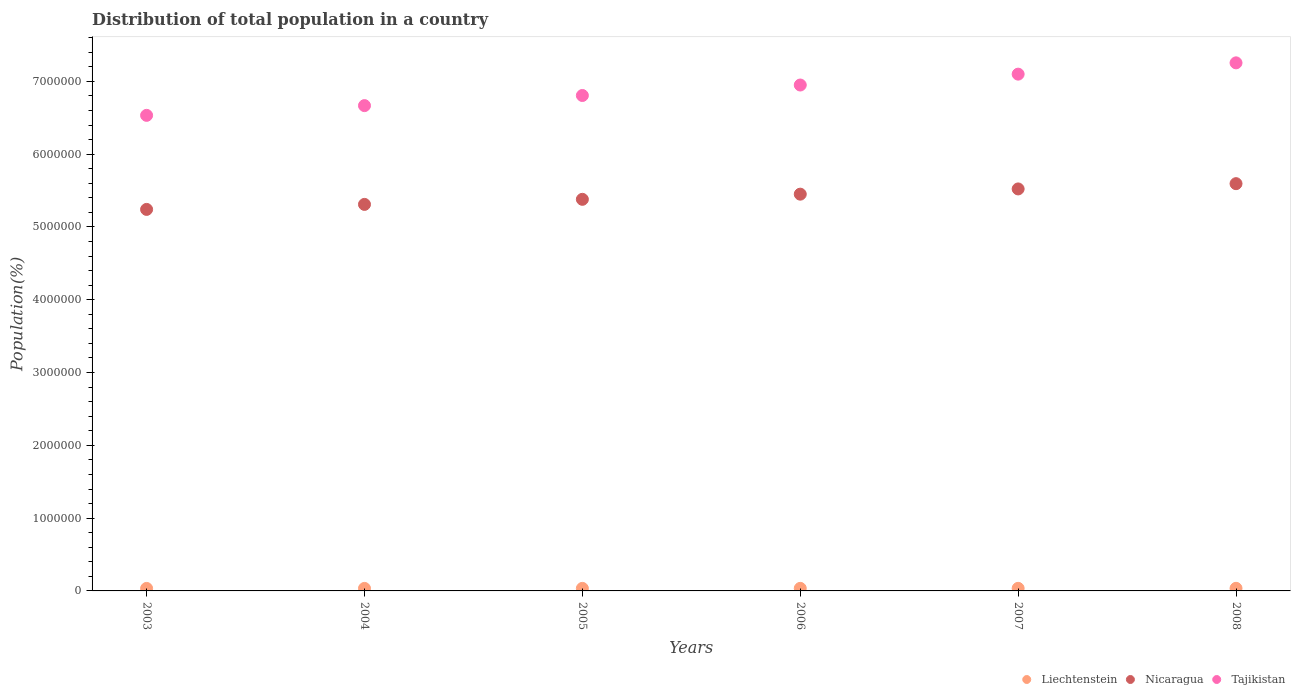Is the number of dotlines equal to the number of legend labels?
Offer a very short reply. Yes. What is the population of in Liechtenstein in 2005?
Provide a short and direct response. 3.49e+04. Across all years, what is the maximum population of in Liechtenstein?
Offer a terse response. 3.57e+04. Across all years, what is the minimum population of in Nicaragua?
Provide a short and direct response. 5.24e+06. In which year was the population of in Liechtenstein maximum?
Make the answer very short. 2008. What is the total population of in Nicaragua in the graph?
Provide a short and direct response. 3.25e+07. What is the difference between the population of in Nicaragua in 2006 and that in 2007?
Give a very brief answer. -7.19e+04. What is the difference between the population of in Nicaragua in 2003 and the population of in Liechtenstein in 2008?
Offer a terse response. 5.21e+06. What is the average population of in Nicaragua per year?
Provide a succinct answer. 5.42e+06. In the year 2007, what is the difference between the population of in Nicaragua and population of in Tajikistan?
Your answer should be very brief. -1.58e+06. In how many years, is the population of in Nicaragua greater than 5200000 %?
Your answer should be compact. 6. What is the ratio of the population of in Liechtenstein in 2003 to that in 2006?
Your answer should be compact. 0.98. Is the population of in Liechtenstein in 2004 less than that in 2005?
Your response must be concise. Yes. What is the difference between the highest and the second highest population of in Nicaragua?
Offer a very short reply. 7.24e+04. What is the difference between the highest and the lowest population of in Tajikistan?
Provide a succinct answer. 7.21e+05. In how many years, is the population of in Liechtenstein greater than the average population of in Liechtenstein taken over all years?
Your answer should be compact. 3. Does the population of in Nicaragua monotonically increase over the years?
Ensure brevity in your answer.  Yes. Is the population of in Tajikistan strictly greater than the population of in Liechtenstein over the years?
Provide a short and direct response. Yes. How many years are there in the graph?
Your answer should be very brief. 6. What is the difference between two consecutive major ticks on the Y-axis?
Your response must be concise. 1.00e+06. Where does the legend appear in the graph?
Ensure brevity in your answer.  Bottom right. How are the legend labels stacked?
Your response must be concise. Horizontal. What is the title of the graph?
Your answer should be very brief. Distribution of total population in a country. What is the label or title of the X-axis?
Provide a short and direct response. Years. What is the label or title of the Y-axis?
Make the answer very short. Population(%). What is the Population(%) in Liechtenstein in 2003?
Make the answer very short. 3.43e+04. What is the Population(%) in Nicaragua in 2003?
Keep it short and to the point. 5.24e+06. What is the Population(%) of Tajikistan in 2003?
Your answer should be compact. 6.53e+06. What is the Population(%) of Liechtenstein in 2004?
Offer a terse response. 3.46e+04. What is the Population(%) in Nicaragua in 2004?
Offer a terse response. 5.31e+06. What is the Population(%) in Tajikistan in 2004?
Make the answer very short. 6.67e+06. What is the Population(%) of Liechtenstein in 2005?
Offer a very short reply. 3.49e+04. What is the Population(%) of Nicaragua in 2005?
Provide a short and direct response. 5.38e+06. What is the Population(%) of Tajikistan in 2005?
Your answer should be compact. 6.81e+06. What is the Population(%) in Liechtenstein in 2006?
Keep it short and to the point. 3.51e+04. What is the Population(%) in Nicaragua in 2006?
Make the answer very short. 5.45e+06. What is the Population(%) of Tajikistan in 2006?
Offer a very short reply. 6.95e+06. What is the Population(%) of Liechtenstein in 2007?
Make the answer very short. 3.54e+04. What is the Population(%) of Nicaragua in 2007?
Your response must be concise. 5.52e+06. What is the Population(%) in Tajikistan in 2007?
Give a very brief answer. 7.10e+06. What is the Population(%) of Liechtenstein in 2008?
Keep it short and to the point. 3.57e+04. What is the Population(%) in Nicaragua in 2008?
Provide a succinct answer. 5.59e+06. What is the Population(%) of Tajikistan in 2008?
Give a very brief answer. 7.25e+06. Across all years, what is the maximum Population(%) of Liechtenstein?
Offer a very short reply. 3.57e+04. Across all years, what is the maximum Population(%) of Nicaragua?
Ensure brevity in your answer.  5.59e+06. Across all years, what is the maximum Population(%) in Tajikistan?
Offer a terse response. 7.25e+06. Across all years, what is the minimum Population(%) of Liechtenstein?
Provide a short and direct response. 3.43e+04. Across all years, what is the minimum Population(%) in Nicaragua?
Ensure brevity in your answer.  5.24e+06. Across all years, what is the minimum Population(%) of Tajikistan?
Offer a terse response. 6.53e+06. What is the total Population(%) of Liechtenstein in the graph?
Offer a very short reply. 2.10e+05. What is the total Population(%) in Nicaragua in the graph?
Offer a very short reply. 3.25e+07. What is the total Population(%) in Tajikistan in the graph?
Your response must be concise. 4.13e+07. What is the difference between the Population(%) of Liechtenstein in 2003 and that in 2004?
Offer a terse response. -279. What is the difference between the Population(%) of Nicaragua in 2003 and that in 2004?
Your answer should be compact. -6.88e+04. What is the difference between the Population(%) of Tajikistan in 2003 and that in 2004?
Your response must be concise. -1.34e+05. What is the difference between the Population(%) in Liechtenstein in 2003 and that in 2005?
Your answer should be compact. -562. What is the difference between the Population(%) of Nicaragua in 2003 and that in 2005?
Ensure brevity in your answer.  -1.38e+05. What is the difference between the Population(%) of Tajikistan in 2003 and that in 2005?
Offer a terse response. -2.73e+05. What is the difference between the Population(%) of Liechtenstein in 2003 and that in 2006?
Your answer should be very brief. -851. What is the difference between the Population(%) of Nicaragua in 2003 and that in 2006?
Make the answer very short. -2.09e+05. What is the difference between the Population(%) in Tajikistan in 2003 and that in 2006?
Offer a very short reply. -4.17e+05. What is the difference between the Population(%) of Liechtenstein in 2003 and that in 2007?
Make the answer very short. -1141. What is the difference between the Population(%) in Nicaragua in 2003 and that in 2007?
Keep it short and to the point. -2.81e+05. What is the difference between the Population(%) in Tajikistan in 2003 and that in 2007?
Your answer should be compact. -5.66e+05. What is the difference between the Population(%) in Liechtenstein in 2003 and that in 2008?
Make the answer very short. -1431. What is the difference between the Population(%) of Nicaragua in 2003 and that in 2008?
Provide a succinct answer. -3.54e+05. What is the difference between the Population(%) in Tajikistan in 2003 and that in 2008?
Your answer should be compact. -7.21e+05. What is the difference between the Population(%) in Liechtenstein in 2004 and that in 2005?
Make the answer very short. -283. What is the difference between the Population(%) of Nicaragua in 2004 and that in 2005?
Ensure brevity in your answer.  -6.96e+04. What is the difference between the Population(%) in Tajikistan in 2004 and that in 2005?
Keep it short and to the point. -1.39e+05. What is the difference between the Population(%) of Liechtenstein in 2004 and that in 2006?
Keep it short and to the point. -572. What is the difference between the Population(%) in Nicaragua in 2004 and that in 2006?
Make the answer very short. -1.41e+05. What is the difference between the Population(%) in Tajikistan in 2004 and that in 2006?
Offer a terse response. -2.83e+05. What is the difference between the Population(%) in Liechtenstein in 2004 and that in 2007?
Ensure brevity in your answer.  -862. What is the difference between the Population(%) in Nicaragua in 2004 and that in 2007?
Your answer should be compact. -2.12e+05. What is the difference between the Population(%) in Tajikistan in 2004 and that in 2007?
Keep it short and to the point. -4.32e+05. What is the difference between the Population(%) of Liechtenstein in 2004 and that in 2008?
Your answer should be compact. -1152. What is the difference between the Population(%) in Nicaragua in 2004 and that in 2008?
Provide a succinct answer. -2.85e+05. What is the difference between the Population(%) in Tajikistan in 2004 and that in 2008?
Your response must be concise. -5.87e+05. What is the difference between the Population(%) in Liechtenstein in 2005 and that in 2006?
Provide a short and direct response. -289. What is the difference between the Population(%) of Nicaragua in 2005 and that in 2006?
Give a very brief answer. -7.09e+04. What is the difference between the Population(%) of Tajikistan in 2005 and that in 2006?
Your response must be concise. -1.44e+05. What is the difference between the Population(%) in Liechtenstein in 2005 and that in 2007?
Offer a terse response. -579. What is the difference between the Population(%) of Nicaragua in 2005 and that in 2007?
Offer a terse response. -1.43e+05. What is the difference between the Population(%) in Tajikistan in 2005 and that in 2007?
Ensure brevity in your answer.  -2.93e+05. What is the difference between the Population(%) of Liechtenstein in 2005 and that in 2008?
Ensure brevity in your answer.  -869. What is the difference between the Population(%) in Nicaragua in 2005 and that in 2008?
Make the answer very short. -2.15e+05. What is the difference between the Population(%) in Tajikistan in 2005 and that in 2008?
Your answer should be very brief. -4.48e+05. What is the difference between the Population(%) of Liechtenstein in 2006 and that in 2007?
Keep it short and to the point. -290. What is the difference between the Population(%) in Nicaragua in 2006 and that in 2007?
Your response must be concise. -7.19e+04. What is the difference between the Population(%) in Tajikistan in 2006 and that in 2007?
Offer a very short reply. -1.49e+05. What is the difference between the Population(%) of Liechtenstein in 2006 and that in 2008?
Your answer should be compact. -580. What is the difference between the Population(%) in Nicaragua in 2006 and that in 2008?
Make the answer very short. -1.44e+05. What is the difference between the Population(%) of Tajikistan in 2006 and that in 2008?
Give a very brief answer. -3.05e+05. What is the difference between the Population(%) of Liechtenstein in 2007 and that in 2008?
Give a very brief answer. -290. What is the difference between the Population(%) of Nicaragua in 2007 and that in 2008?
Give a very brief answer. -7.24e+04. What is the difference between the Population(%) in Tajikistan in 2007 and that in 2008?
Offer a very short reply. -1.55e+05. What is the difference between the Population(%) in Liechtenstein in 2003 and the Population(%) in Nicaragua in 2004?
Offer a terse response. -5.28e+06. What is the difference between the Population(%) in Liechtenstein in 2003 and the Population(%) in Tajikistan in 2004?
Ensure brevity in your answer.  -6.63e+06. What is the difference between the Population(%) of Nicaragua in 2003 and the Population(%) of Tajikistan in 2004?
Make the answer very short. -1.43e+06. What is the difference between the Population(%) of Liechtenstein in 2003 and the Population(%) of Nicaragua in 2005?
Ensure brevity in your answer.  -5.35e+06. What is the difference between the Population(%) in Liechtenstein in 2003 and the Population(%) in Tajikistan in 2005?
Provide a short and direct response. -6.77e+06. What is the difference between the Population(%) in Nicaragua in 2003 and the Population(%) in Tajikistan in 2005?
Make the answer very short. -1.56e+06. What is the difference between the Population(%) in Liechtenstein in 2003 and the Population(%) in Nicaragua in 2006?
Your answer should be compact. -5.42e+06. What is the difference between the Population(%) of Liechtenstein in 2003 and the Population(%) of Tajikistan in 2006?
Your answer should be compact. -6.92e+06. What is the difference between the Population(%) of Nicaragua in 2003 and the Population(%) of Tajikistan in 2006?
Your answer should be compact. -1.71e+06. What is the difference between the Population(%) in Liechtenstein in 2003 and the Population(%) in Nicaragua in 2007?
Offer a very short reply. -5.49e+06. What is the difference between the Population(%) of Liechtenstein in 2003 and the Population(%) of Tajikistan in 2007?
Provide a short and direct response. -7.06e+06. What is the difference between the Population(%) of Nicaragua in 2003 and the Population(%) of Tajikistan in 2007?
Offer a very short reply. -1.86e+06. What is the difference between the Population(%) in Liechtenstein in 2003 and the Population(%) in Nicaragua in 2008?
Ensure brevity in your answer.  -5.56e+06. What is the difference between the Population(%) of Liechtenstein in 2003 and the Population(%) of Tajikistan in 2008?
Your answer should be compact. -7.22e+06. What is the difference between the Population(%) in Nicaragua in 2003 and the Population(%) in Tajikistan in 2008?
Your response must be concise. -2.01e+06. What is the difference between the Population(%) of Liechtenstein in 2004 and the Population(%) of Nicaragua in 2005?
Provide a succinct answer. -5.34e+06. What is the difference between the Population(%) in Liechtenstein in 2004 and the Population(%) in Tajikistan in 2005?
Provide a succinct answer. -6.77e+06. What is the difference between the Population(%) of Nicaragua in 2004 and the Population(%) of Tajikistan in 2005?
Your answer should be compact. -1.50e+06. What is the difference between the Population(%) of Liechtenstein in 2004 and the Population(%) of Nicaragua in 2006?
Your answer should be very brief. -5.42e+06. What is the difference between the Population(%) of Liechtenstein in 2004 and the Population(%) of Tajikistan in 2006?
Give a very brief answer. -6.91e+06. What is the difference between the Population(%) in Nicaragua in 2004 and the Population(%) in Tajikistan in 2006?
Give a very brief answer. -1.64e+06. What is the difference between the Population(%) in Liechtenstein in 2004 and the Population(%) in Nicaragua in 2007?
Your answer should be very brief. -5.49e+06. What is the difference between the Population(%) of Liechtenstein in 2004 and the Population(%) of Tajikistan in 2007?
Your response must be concise. -7.06e+06. What is the difference between the Population(%) in Nicaragua in 2004 and the Population(%) in Tajikistan in 2007?
Keep it short and to the point. -1.79e+06. What is the difference between the Population(%) in Liechtenstein in 2004 and the Population(%) in Nicaragua in 2008?
Provide a short and direct response. -5.56e+06. What is the difference between the Population(%) of Liechtenstein in 2004 and the Population(%) of Tajikistan in 2008?
Provide a succinct answer. -7.22e+06. What is the difference between the Population(%) in Nicaragua in 2004 and the Population(%) in Tajikistan in 2008?
Your answer should be compact. -1.94e+06. What is the difference between the Population(%) of Liechtenstein in 2005 and the Population(%) of Nicaragua in 2006?
Your answer should be compact. -5.42e+06. What is the difference between the Population(%) of Liechtenstein in 2005 and the Population(%) of Tajikistan in 2006?
Ensure brevity in your answer.  -6.91e+06. What is the difference between the Population(%) of Nicaragua in 2005 and the Population(%) of Tajikistan in 2006?
Offer a very short reply. -1.57e+06. What is the difference between the Population(%) of Liechtenstein in 2005 and the Population(%) of Nicaragua in 2007?
Your answer should be very brief. -5.49e+06. What is the difference between the Population(%) in Liechtenstein in 2005 and the Population(%) in Tajikistan in 2007?
Your response must be concise. -7.06e+06. What is the difference between the Population(%) in Nicaragua in 2005 and the Population(%) in Tajikistan in 2007?
Give a very brief answer. -1.72e+06. What is the difference between the Population(%) in Liechtenstein in 2005 and the Population(%) in Nicaragua in 2008?
Offer a terse response. -5.56e+06. What is the difference between the Population(%) of Liechtenstein in 2005 and the Population(%) of Tajikistan in 2008?
Your answer should be very brief. -7.22e+06. What is the difference between the Population(%) of Nicaragua in 2005 and the Population(%) of Tajikistan in 2008?
Provide a short and direct response. -1.87e+06. What is the difference between the Population(%) of Liechtenstein in 2006 and the Population(%) of Nicaragua in 2007?
Make the answer very short. -5.49e+06. What is the difference between the Population(%) of Liechtenstein in 2006 and the Population(%) of Tajikistan in 2007?
Provide a succinct answer. -7.06e+06. What is the difference between the Population(%) of Nicaragua in 2006 and the Population(%) of Tajikistan in 2007?
Offer a very short reply. -1.65e+06. What is the difference between the Population(%) in Liechtenstein in 2006 and the Population(%) in Nicaragua in 2008?
Keep it short and to the point. -5.56e+06. What is the difference between the Population(%) of Liechtenstein in 2006 and the Population(%) of Tajikistan in 2008?
Provide a succinct answer. -7.22e+06. What is the difference between the Population(%) of Nicaragua in 2006 and the Population(%) of Tajikistan in 2008?
Your answer should be compact. -1.80e+06. What is the difference between the Population(%) in Liechtenstein in 2007 and the Population(%) in Nicaragua in 2008?
Ensure brevity in your answer.  -5.56e+06. What is the difference between the Population(%) in Liechtenstein in 2007 and the Population(%) in Tajikistan in 2008?
Offer a very short reply. -7.22e+06. What is the difference between the Population(%) of Nicaragua in 2007 and the Population(%) of Tajikistan in 2008?
Your answer should be very brief. -1.73e+06. What is the average Population(%) in Liechtenstein per year?
Offer a very short reply. 3.50e+04. What is the average Population(%) in Nicaragua per year?
Offer a terse response. 5.42e+06. What is the average Population(%) of Tajikistan per year?
Offer a very short reply. 6.88e+06. In the year 2003, what is the difference between the Population(%) of Liechtenstein and Population(%) of Nicaragua?
Your response must be concise. -5.21e+06. In the year 2003, what is the difference between the Population(%) of Liechtenstein and Population(%) of Tajikistan?
Provide a succinct answer. -6.50e+06. In the year 2003, what is the difference between the Population(%) of Nicaragua and Population(%) of Tajikistan?
Give a very brief answer. -1.29e+06. In the year 2004, what is the difference between the Population(%) of Liechtenstein and Population(%) of Nicaragua?
Give a very brief answer. -5.28e+06. In the year 2004, what is the difference between the Population(%) in Liechtenstein and Population(%) in Tajikistan?
Offer a very short reply. -6.63e+06. In the year 2004, what is the difference between the Population(%) in Nicaragua and Population(%) in Tajikistan?
Give a very brief answer. -1.36e+06. In the year 2005, what is the difference between the Population(%) in Liechtenstein and Population(%) in Nicaragua?
Offer a very short reply. -5.34e+06. In the year 2005, what is the difference between the Population(%) in Liechtenstein and Population(%) in Tajikistan?
Make the answer very short. -6.77e+06. In the year 2005, what is the difference between the Population(%) of Nicaragua and Population(%) of Tajikistan?
Provide a succinct answer. -1.43e+06. In the year 2006, what is the difference between the Population(%) of Liechtenstein and Population(%) of Nicaragua?
Give a very brief answer. -5.42e+06. In the year 2006, what is the difference between the Population(%) in Liechtenstein and Population(%) in Tajikistan?
Your answer should be compact. -6.91e+06. In the year 2006, what is the difference between the Population(%) of Nicaragua and Population(%) of Tajikistan?
Offer a terse response. -1.50e+06. In the year 2007, what is the difference between the Population(%) of Liechtenstein and Population(%) of Nicaragua?
Provide a succinct answer. -5.49e+06. In the year 2007, what is the difference between the Population(%) of Liechtenstein and Population(%) of Tajikistan?
Your answer should be compact. -7.06e+06. In the year 2007, what is the difference between the Population(%) of Nicaragua and Population(%) of Tajikistan?
Provide a succinct answer. -1.58e+06. In the year 2008, what is the difference between the Population(%) in Liechtenstein and Population(%) in Nicaragua?
Keep it short and to the point. -5.56e+06. In the year 2008, what is the difference between the Population(%) of Liechtenstein and Population(%) of Tajikistan?
Your answer should be very brief. -7.22e+06. In the year 2008, what is the difference between the Population(%) in Nicaragua and Population(%) in Tajikistan?
Offer a terse response. -1.66e+06. What is the ratio of the Population(%) of Tajikistan in 2003 to that in 2004?
Your answer should be compact. 0.98. What is the ratio of the Population(%) in Liechtenstein in 2003 to that in 2005?
Give a very brief answer. 0.98. What is the ratio of the Population(%) of Nicaragua in 2003 to that in 2005?
Ensure brevity in your answer.  0.97. What is the ratio of the Population(%) in Tajikistan in 2003 to that in 2005?
Make the answer very short. 0.96. What is the ratio of the Population(%) in Liechtenstein in 2003 to that in 2006?
Give a very brief answer. 0.98. What is the ratio of the Population(%) in Nicaragua in 2003 to that in 2006?
Provide a short and direct response. 0.96. What is the ratio of the Population(%) in Tajikistan in 2003 to that in 2006?
Provide a short and direct response. 0.94. What is the ratio of the Population(%) of Liechtenstein in 2003 to that in 2007?
Provide a succinct answer. 0.97. What is the ratio of the Population(%) in Nicaragua in 2003 to that in 2007?
Ensure brevity in your answer.  0.95. What is the ratio of the Population(%) of Tajikistan in 2003 to that in 2007?
Your answer should be very brief. 0.92. What is the ratio of the Population(%) of Liechtenstein in 2003 to that in 2008?
Provide a succinct answer. 0.96. What is the ratio of the Population(%) of Nicaragua in 2003 to that in 2008?
Your response must be concise. 0.94. What is the ratio of the Population(%) in Tajikistan in 2003 to that in 2008?
Offer a terse response. 0.9. What is the ratio of the Population(%) in Nicaragua in 2004 to that in 2005?
Your response must be concise. 0.99. What is the ratio of the Population(%) of Tajikistan in 2004 to that in 2005?
Keep it short and to the point. 0.98. What is the ratio of the Population(%) of Liechtenstein in 2004 to that in 2006?
Give a very brief answer. 0.98. What is the ratio of the Population(%) in Nicaragua in 2004 to that in 2006?
Your answer should be very brief. 0.97. What is the ratio of the Population(%) in Tajikistan in 2004 to that in 2006?
Provide a succinct answer. 0.96. What is the ratio of the Population(%) in Liechtenstein in 2004 to that in 2007?
Keep it short and to the point. 0.98. What is the ratio of the Population(%) of Nicaragua in 2004 to that in 2007?
Give a very brief answer. 0.96. What is the ratio of the Population(%) in Tajikistan in 2004 to that in 2007?
Your response must be concise. 0.94. What is the ratio of the Population(%) of Liechtenstein in 2004 to that in 2008?
Ensure brevity in your answer.  0.97. What is the ratio of the Population(%) of Nicaragua in 2004 to that in 2008?
Offer a terse response. 0.95. What is the ratio of the Population(%) of Tajikistan in 2004 to that in 2008?
Provide a short and direct response. 0.92. What is the ratio of the Population(%) in Liechtenstein in 2005 to that in 2006?
Your answer should be compact. 0.99. What is the ratio of the Population(%) in Tajikistan in 2005 to that in 2006?
Provide a succinct answer. 0.98. What is the ratio of the Population(%) of Liechtenstein in 2005 to that in 2007?
Your answer should be compact. 0.98. What is the ratio of the Population(%) of Nicaragua in 2005 to that in 2007?
Make the answer very short. 0.97. What is the ratio of the Population(%) in Tajikistan in 2005 to that in 2007?
Ensure brevity in your answer.  0.96. What is the ratio of the Population(%) in Liechtenstein in 2005 to that in 2008?
Provide a short and direct response. 0.98. What is the ratio of the Population(%) in Nicaragua in 2005 to that in 2008?
Keep it short and to the point. 0.96. What is the ratio of the Population(%) of Tajikistan in 2005 to that in 2008?
Provide a succinct answer. 0.94. What is the ratio of the Population(%) of Liechtenstein in 2006 to that in 2007?
Offer a terse response. 0.99. What is the ratio of the Population(%) in Nicaragua in 2006 to that in 2007?
Your answer should be compact. 0.99. What is the ratio of the Population(%) in Tajikistan in 2006 to that in 2007?
Give a very brief answer. 0.98. What is the ratio of the Population(%) in Liechtenstein in 2006 to that in 2008?
Your answer should be very brief. 0.98. What is the ratio of the Population(%) in Nicaragua in 2006 to that in 2008?
Give a very brief answer. 0.97. What is the ratio of the Population(%) in Tajikistan in 2006 to that in 2008?
Provide a succinct answer. 0.96. What is the ratio of the Population(%) in Liechtenstein in 2007 to that in 2008?
Offer a terse response. 0.99. What is the ratio of the Population(%) of Nicaragua in 2007 to that in 2008?
Your response must be concise. 0.99. What is the ratio of the Population(%) in Tajikistan in 2007 to that in 2008?
Your response must be concise. 0.98. What is the difference between the highest and the second highest Population(%) in Liechtenstein?
Offer a very short reply. 290. What is the difference between the highest and the second highest Population(%) in Nicaragua?
Keep it short and to the point. 7.24e+04. What is the difference between the highest and the second highest Population(%) of Tajikistan?
Your response must be concise. 1.55e+05. What is the difference between the highest and the lowest Population(%) in Liechtenstein?
Keep it short and to the point. 1431. What is the difference between the highest and the lowest Population(%) of Nicaragua?
Offer a very short reply. 3.54e+05. What is the difference between the highest and the lowest Population(%) in Tajikistan?
Offer a very short reply. 7.21e+05. 